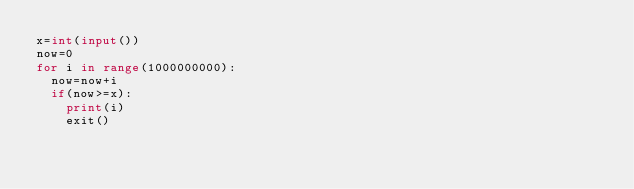<code> <loc_0><loc_0><loc_500><loc_500><_Python_>x=int(input())
now=0
for i in range(1000000000):
  now=now+i
  if(now>=x):
    print(i)
    exit()</code> 